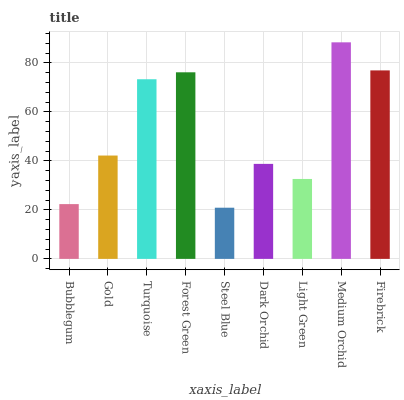Is Steel Blue the minimum?
Answer yes or no. Yes. Is Medium Orchid the maximum?
Answer yes or no. Yes. Is Gold the minimum?
Answer yes or no. No. Is Gold the maximum?
Answer yes or no. No. Is Gold greater than Bubblegum?
Answer yes or no. Yes. Is Bubblegum less than Gold?
Answer yes or no. Yes. Is Bubblegum greater than Gold?
Answer yes or no. No. Is Gold less than Bubblegum?
Answer yes or no. No. Is Gold the high median?
Answer yes or no. Yes. Is Gold the low median?
Answer yes or no. Yes. Is Firebrick the high median?
Answer yes or no. No. Is Medium Orchid the low median?
Answer yes or no. No. 